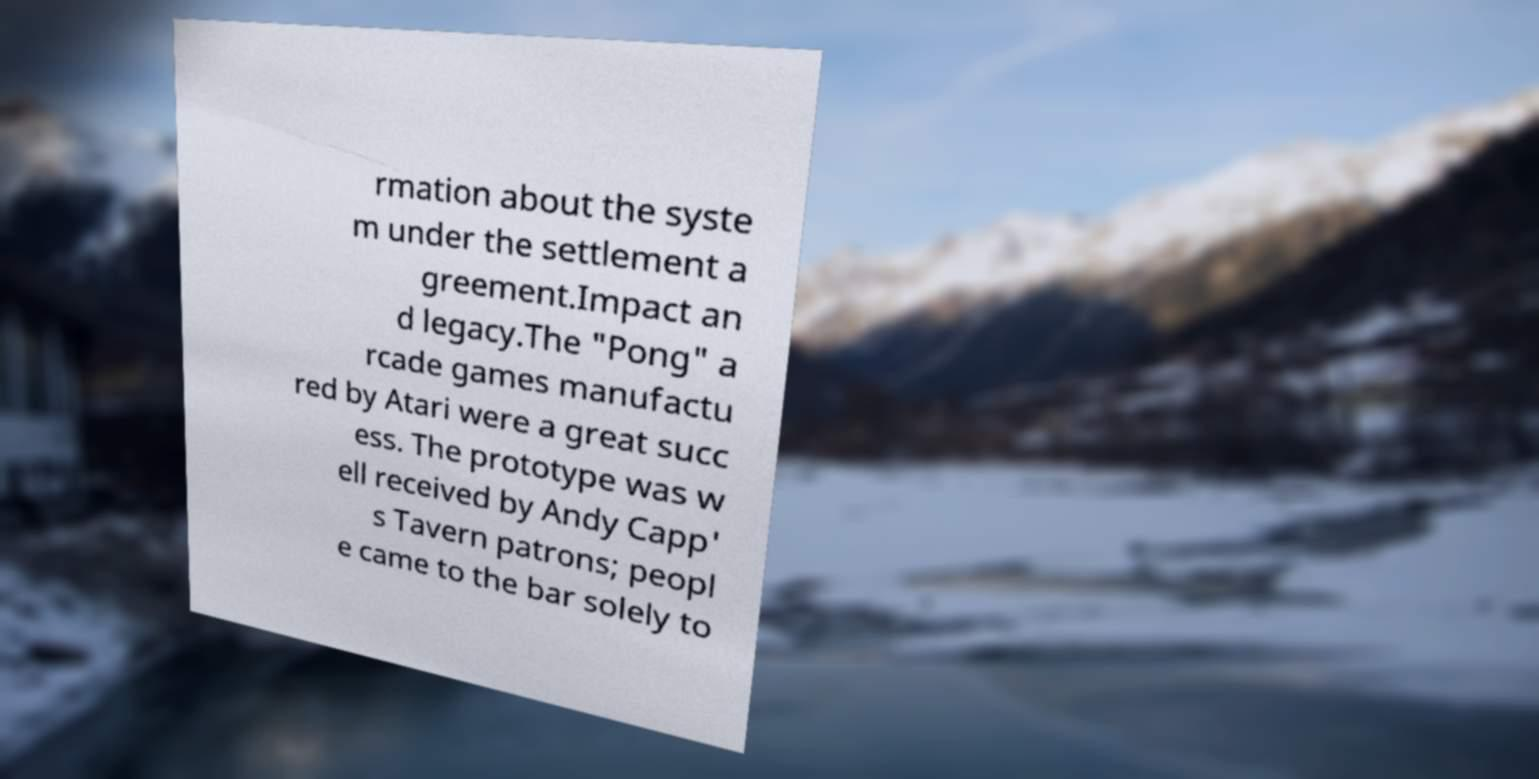Could you assist in decoding the text presented in this image and type it out clearly? rmation about the syste m under the settlement a greement.Impact an d legacy.The "Pong" a rcade games manufactu red by Atari were a great succ ess. The prototype was w ell received by Andy Capp' s Tavern patrons; peopl e came to the bar solely to 